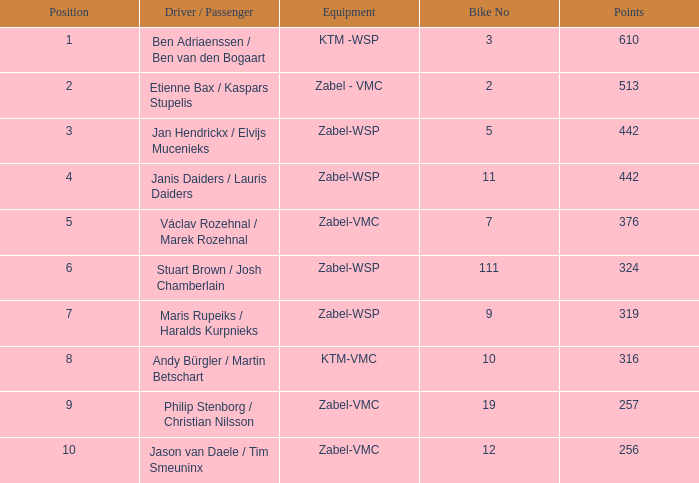What is the most elevated Position that has a Points of 257, and a Bike No littler than 19? None. 